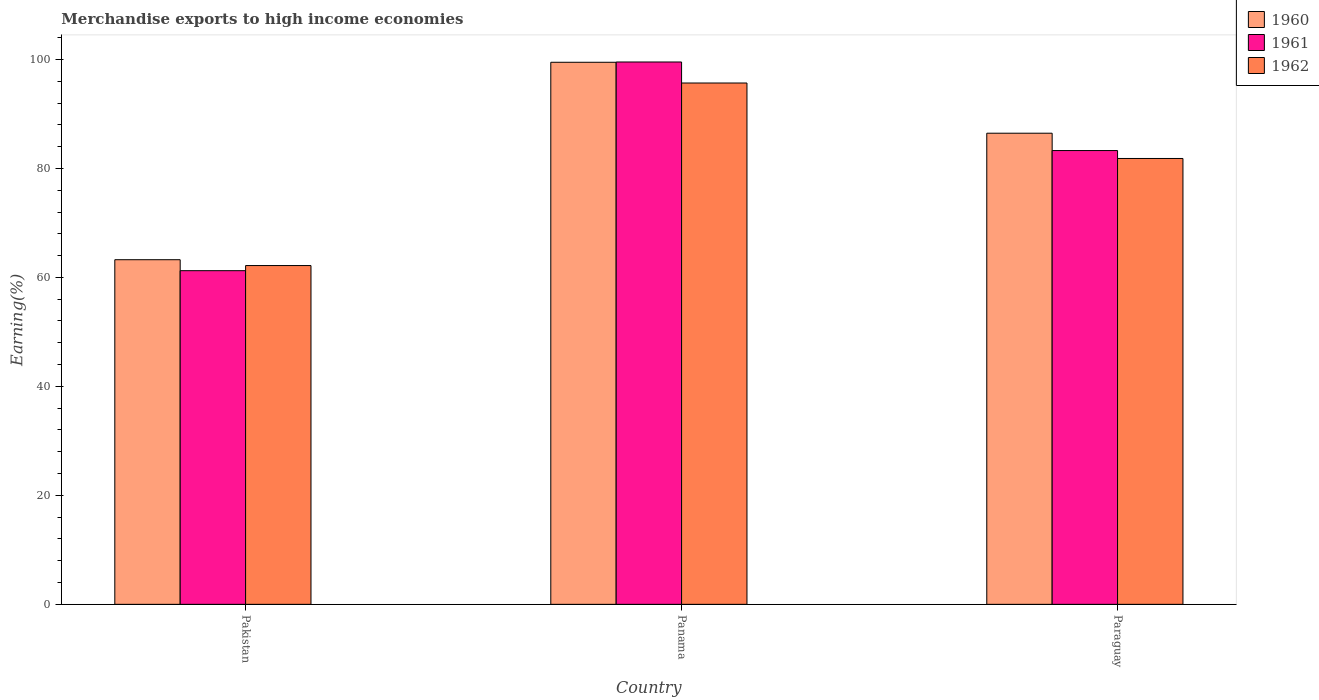How many different coloured bars are there?
Your answer should be compact. 3. How many groups of bars are there?
Ensure brevity in your answer.  3. How many bars are there on the 2nd tick from the left?
Give a very brief answer. 3. How many bars are there on the 2nd tick from the right?
Your response must be concise. 3. What is the label of the 2nd group of bars from the left?
Offer a very short reply. Panama. What is the percentage of amount earned from merchandise exports in 1962 in Panama?
Make the answer very short. 95.68. Across all countries, what is the maximum percentage of amount earned from merchandise exports in 1960?
Keep it short and to the point. 99.48. Across all countries, what is the minimum percentage of amount earned from merchandise exports in 1961?
Ensure brevity in your answer.  61.23. In which country was the percentage of amount earned from merchandise exports in 1961 maximum?
Your answer should be very brief. Panama. In which country was the percentage of amount earned from merchandise exports in 1960 minimum?
Provide a short and direct response. Pakistan. What is the total percentage of amount earned from merchandise exports in 1962 in the graph?
Your answer should be very brief. 239.68. What is the difference between the percentage of amount earned from merchandise exports in 1961 in Pakistan and that in Panama?
Offer a terse response. -38.3. What is the difference between the percentage of amount earned from merchandise exports in 1962 in Paraguay and the percentage of amount earned from merchandise exports in 1961 in Panama?
Your answer should be very brief. -17.71. What is the average percentage of amount earned from merchandise exports in 1962 per country?
Your answer should be very brief. 79.89. What is the difference between the percentage of amount earned from merchandise exports of/in 1962 and percentage of amount earned from merchandise exports of/in 1961 in Panama?
Offer a terse response. -3.86. In how many countries, is the percentage of amount earned from merchandise exports in 1960 greater than 48 %?
Provide a succinct answer. 3. What is the ratio of the percentage of amount earned from merchandise exports in 1961 in Pakistan to that in Panama?
Provide a short and direct response. 0.62. Is the percentage of amount earned from merchandise exports in 1962 in Pakistan less than that in Panama?
Ensure brevity in your answer.  Yes. What is the difference between the highest and the second highest percentage of amount earned from merchandise exports in 1960?
Provide a short and direct response. 13.02. What is the difference between the highest and the lowest percentage of amount earned from merchandise exports in 1961?
Your answer should be compact. 38.3. Is the sum of the percentage of amount earned from merchandise exports in 1961 in Pakistan and Paraguay greater than the maximum percentage of amount earned from merchandise exports in 1960 across all countries?
Make the answer very short. Yes. What does the 1st bar from the left in Paraguay represents?
Give a very brief answer. 1960. What does the 1st bar from the right in Panama represents?
Provide a short and direct response. 1962. How many countries are there in the graph?
Give a very brief answer. 3. Are the values on the major ticks of Y-axis written in scientific E-notation?
Your response must be concise. No. Does the graph contain any zero values?
Make the answer very short. No. Does the graph contain grids?
Give a very brief answer. No. Where does the legend appear in the graph?
Your answer should be compact. Top right. How are the legend labels stacked?
Offer a terse response. Vertical. What is the title of the graph?
Your answer should be very brief. Merchandise exports to high income economies. What is the label or title of the X-axis?
Make the answer very short. Country. What is the label or title of the Y-axis?
Offer a terse response. Earning(%). What is the Earning(%) in 1960 in Pakistan?
Your answer should be compact. 63.25. What is the Earning(%) of 1961 in Pakistan?
Provide a succinct answer. 61.23. What is the Earning(%) of 1962 in Pakistan?
Your response must be concise. 62.17. What is the Earning(%) of 1960 in Panama?
Your answer should be compact. 99.48. What is the Earning(%) of 1961 in Panama?
Offer a terse response. 99.53. What is the Earning(%) in 1962 in Panama?
Offer a terse response. 95.68. What is the Earning(%) of 1960 in Paraguay?
Make the answer very short. 86.46. What is the Earning(%) of 1961 in Paraguay?
Give a very brief answer. 83.28. What is the Earning(%) in 1962 in Paraguay?
Ensure brevity in your answer.  81.83. Across all countries, what is the maximum Earning(%) of 1960?
Make the answer very short. 99.48. Across all countries, what is the maximum Earning(%) of 1961?
Provide a succinct answer. 99.53. Across all countries, what is the maximum Earning(%) of 1962?
Ensure brevity in your answer.  95.68. Across all countries, what is the minimum Earning(%) of 1960?
Give a very brief answer. 63.25. Across all countries, what is the minimum Earning(%) of 1961?
Your answer should be very brief. 61.23. Across all countries, what is the minimum Earning(%) in 1962?
Keep it short and to the point. 62.17. What is the total Earning(%) in 1960 in the graph?
Provide a succinct answer. 249.19. What is the total Earning(%) of 1961 in the graph?
Your answer should be very brief. 244.05. What is the total Earning(%) of 1962 in the graph?
Your response must be concise. 239.68. What is the difference between the Earning(%) in 1960 in Pakistan and that in Panama?
Your answer should be very brief. -36.24. What is the difference between the Earning(%) in 1961 in Pakistan and that in Panama?
Provide a succinct answer. -38.3. What is the difference between the Earning(%) of 1962 in Pakistan and that in Panama?
Your answer should be compact. -33.5. What is the difference between the Earning(%) of 1960 in Pakistan and that in Paraguay?
Your response must be concise. -23.22. What is the difference between the Earning(%) in 1961 in Pakistan and that in Paraguay?
Offer a very short reply. -22.05. What is the difference between the Earning(%) in 1962 in Pakistan and that in Paraguay?
Your response must be concise. -19.65. What is the difference between the Earning(%) in 1960 in Panama and that in Paraguay?
Provide a succinct answer. 13.02. What is the difference between the Earning(%) of 1961 in Panama and that in Paraguay?
Offer a very short reply. 16.25. What is the difference between the Earning(%) in 1962 in Panama and that in Paraguay?
Your response must be concise. 13.85. What is the difference between the Earning(%) of 1960 in Pakistan and the Earning(%) of 1961 in Panama?
Your response must be concise. -36.29. What is the difference between the Earning(%) in 1960 in Pakistan and the Earning(%) in 1962 in Panama?
Offer a very short reply. -32.43. What is the difference between the Earning(%) in 1961 in Pakistan and the Earning(%) in 1962 in Panama?
Your answer should be compact. -34.44. What is the difference between the Earning(%) of 1960 in Pakistan and the Earning(%) of 1961 in Paraguay?
Give a very brief answer. -20.03. What is the difference between the Earning(%) in 1960 in Pakistan and the Earning(%) in 1962 in Paraguay?
Your answer should be very brief. -18.58. What is the difference between the Earning(%) in 1961 in Pakistan and the Earning(%) in 1962 in Paraguay?
Provide a succinct answer. -20.59. What is the difference between the Earning(%) in 1960 in Panama and the Earning(%) in 1961 in Paraguay?
Your answer should be very brief. 16.2. What is the difference between the Earning(%) in 1960 in Panama and the Earning(%) in 1962 in Paraguay?
Make the answer very short. 17.66. What is the difference between the Earning(%) of 1961 in Panama and the Earning(%) of 1962 in Paraguay?
Your answer should be very brief. 17.71. What is the average Earning(%) in 1960 per country?
Provide a short and direct response. 83.06. What is the average Earning(%) in 1961 per country?
Provide a short and direct response. 81.35. What is the average Earning(%) in 1962 per country?
Keep it short and to the point. 79.89. What is the difference between the Earning(%) of 1960 and Earning(%) of 1961 in Pakistan?
Offer a very short reply. 2.01. What is the difference between the Earning(%) in 1960 and Earning(%) in 1962 in Pakistan?
Your response must be concise. 1.07. What is the difference between the Earning(%) in 1961 and Earning(%) in 1962 in Pakistan?
Ensure brevity in your answer.  -0.94. What is the difference between the Earning(%) in 1960 and Earning(%) in 1961 in Panama?
Your answer should be compact. -0.05. What is the difference between the Earning(%) of 1960 and Earning(%) of 1962 in Panama?
Offer a terse response. 3.81. What is the difference between the Earning(%) in 1961 and Earning(%) in 1962 in Panama?
Keep it short and to the point. 3.86. What is the difference between the Earning(%) in 1960 and Earning(%) in 1961 in Paraguay?
Ensure brevity in your answer.  3.18. What is the difference between the Earning(%) in 1960 and Earning(%) in 1962 in Paraguay?
Keep it short and to the point. 4.64. What is the difference between the Earning(%) in 1961 and Earning(%) in 1962 in Paraguay?
Your answer should be very brief. 1.45. What is the ratio of the Earning(%) of 1960 in Pakistan to that in Panama?
Offer a very short reply. 0.64. What is the ratio of the Earning(%) in 1961 in Pakistan to that in Panama?
Your answer should be compact. 0.62. What is the ratio of the Earning(%) in 1962 in Pakistan to that in Panama?
Give a very brief answer. 0.65. What is the ratio of the Earning(%) in 1960 in Pakistan to that in Paraguay?
Your answer should be compact. 0.73. What is the ratio of the Earning(%) in 1961 in Pakistan to that in Paraguay?
Ensure brevity in your answer.  0.74. What is the ratio of the Earning(%) in 1962 in Pakistan to that in Paraguay?
Keep it short and to the point. 0.76. What is the ratio of the Earning(%) in 1960 in Panama to that in Paraguay?
Provide a short and direct response. 1.15. What is the ratio of the Earning(%) of 1961 in Panama to that in Paraguay?
Your answer should be very brief. 1.2. What is the ratio of the Earning(%) in 1962 in Panama to that in Paraguay?
Provide a short and direct response. 1.17. What is the difference between the highest and the second highest Earning(%) in 1960?
Keep it short and to the point. 13.02. What is the difference between the highest and the second highest Earning(%) in 1961?
Make the answer very short. 16.25. What is the difference between the highest and the second highest Earning(%) in 1962?
Provide a short and direct response. 13.85. What is the difference between the highest and the lowest Earning(%) of 1960?
Ensure brevity in your answer.  36.24. What is the difference between the highest and the lowest Earning(%) in 1961?
Give a very brief answer. 38.3. What is the difference between the highest and the lowest Earning(%) in 1962?
Provide a short and direct response. 33.5. 